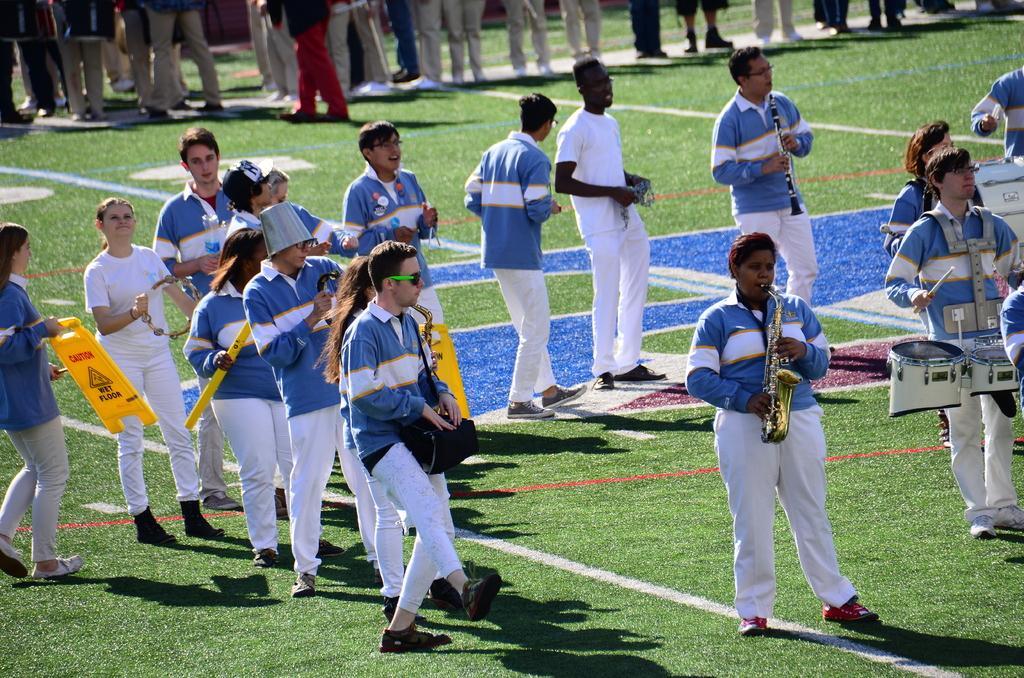Could you give a brief overview of what you see in this image? In the image there are many people in blue shirt playing musical instruments and dancing on the grassland and in the back there are many people standing. 